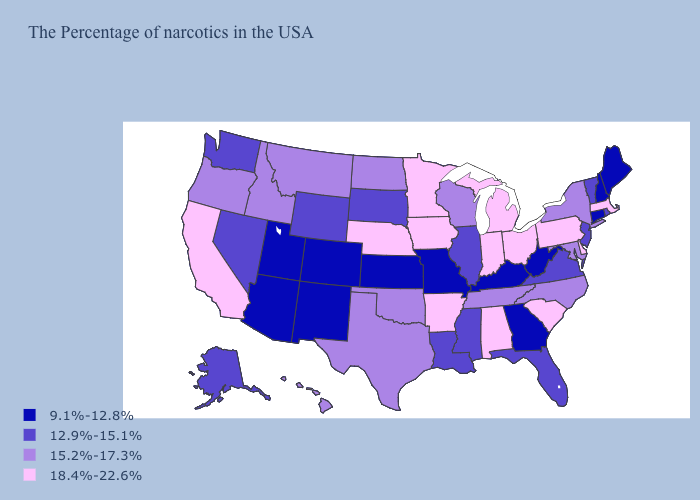Among the states that border Iowa , which have the highest value?
Keep it brief. Minnesota, Nebraska. Does Arizona have the lowest value in the West?
Give a very brief answer. Yes. Does Georgia have the same value as Connecticut?
Be succinct. Yes. What is the highest value in the USA?
Write a very short answer. 18.4%-22.6%. Does Vermont have a lower value than Nebraska?
Answer briefly. Yes. What is the value of Utah?
Quick response, please. 9.1%-12.8%. Among the states that border California , which have the lowest value?
Concise answer only. Arizona. Does Maine have the lowest value in the USA?
Keep it brief. Yes. What is the lowest value in states that border Ohio?
Write a very short answer. 9.1%-12.8%. Does Maine have the highest value in the Northeast?
Give a very brief answer. No. Does Ohio have the highest value in the USA?
Answer briefly. Yes. Is the legend a continuous bar?
Concise answer only. No. Does West Virginia have the lowest value in the South?
Be succinct. Yes. What is the value of Minnesota?
Quick response, please. 18.4%-22.6%. Does Arkansas have the highest value in the USA?
Short answer required. Yes. 